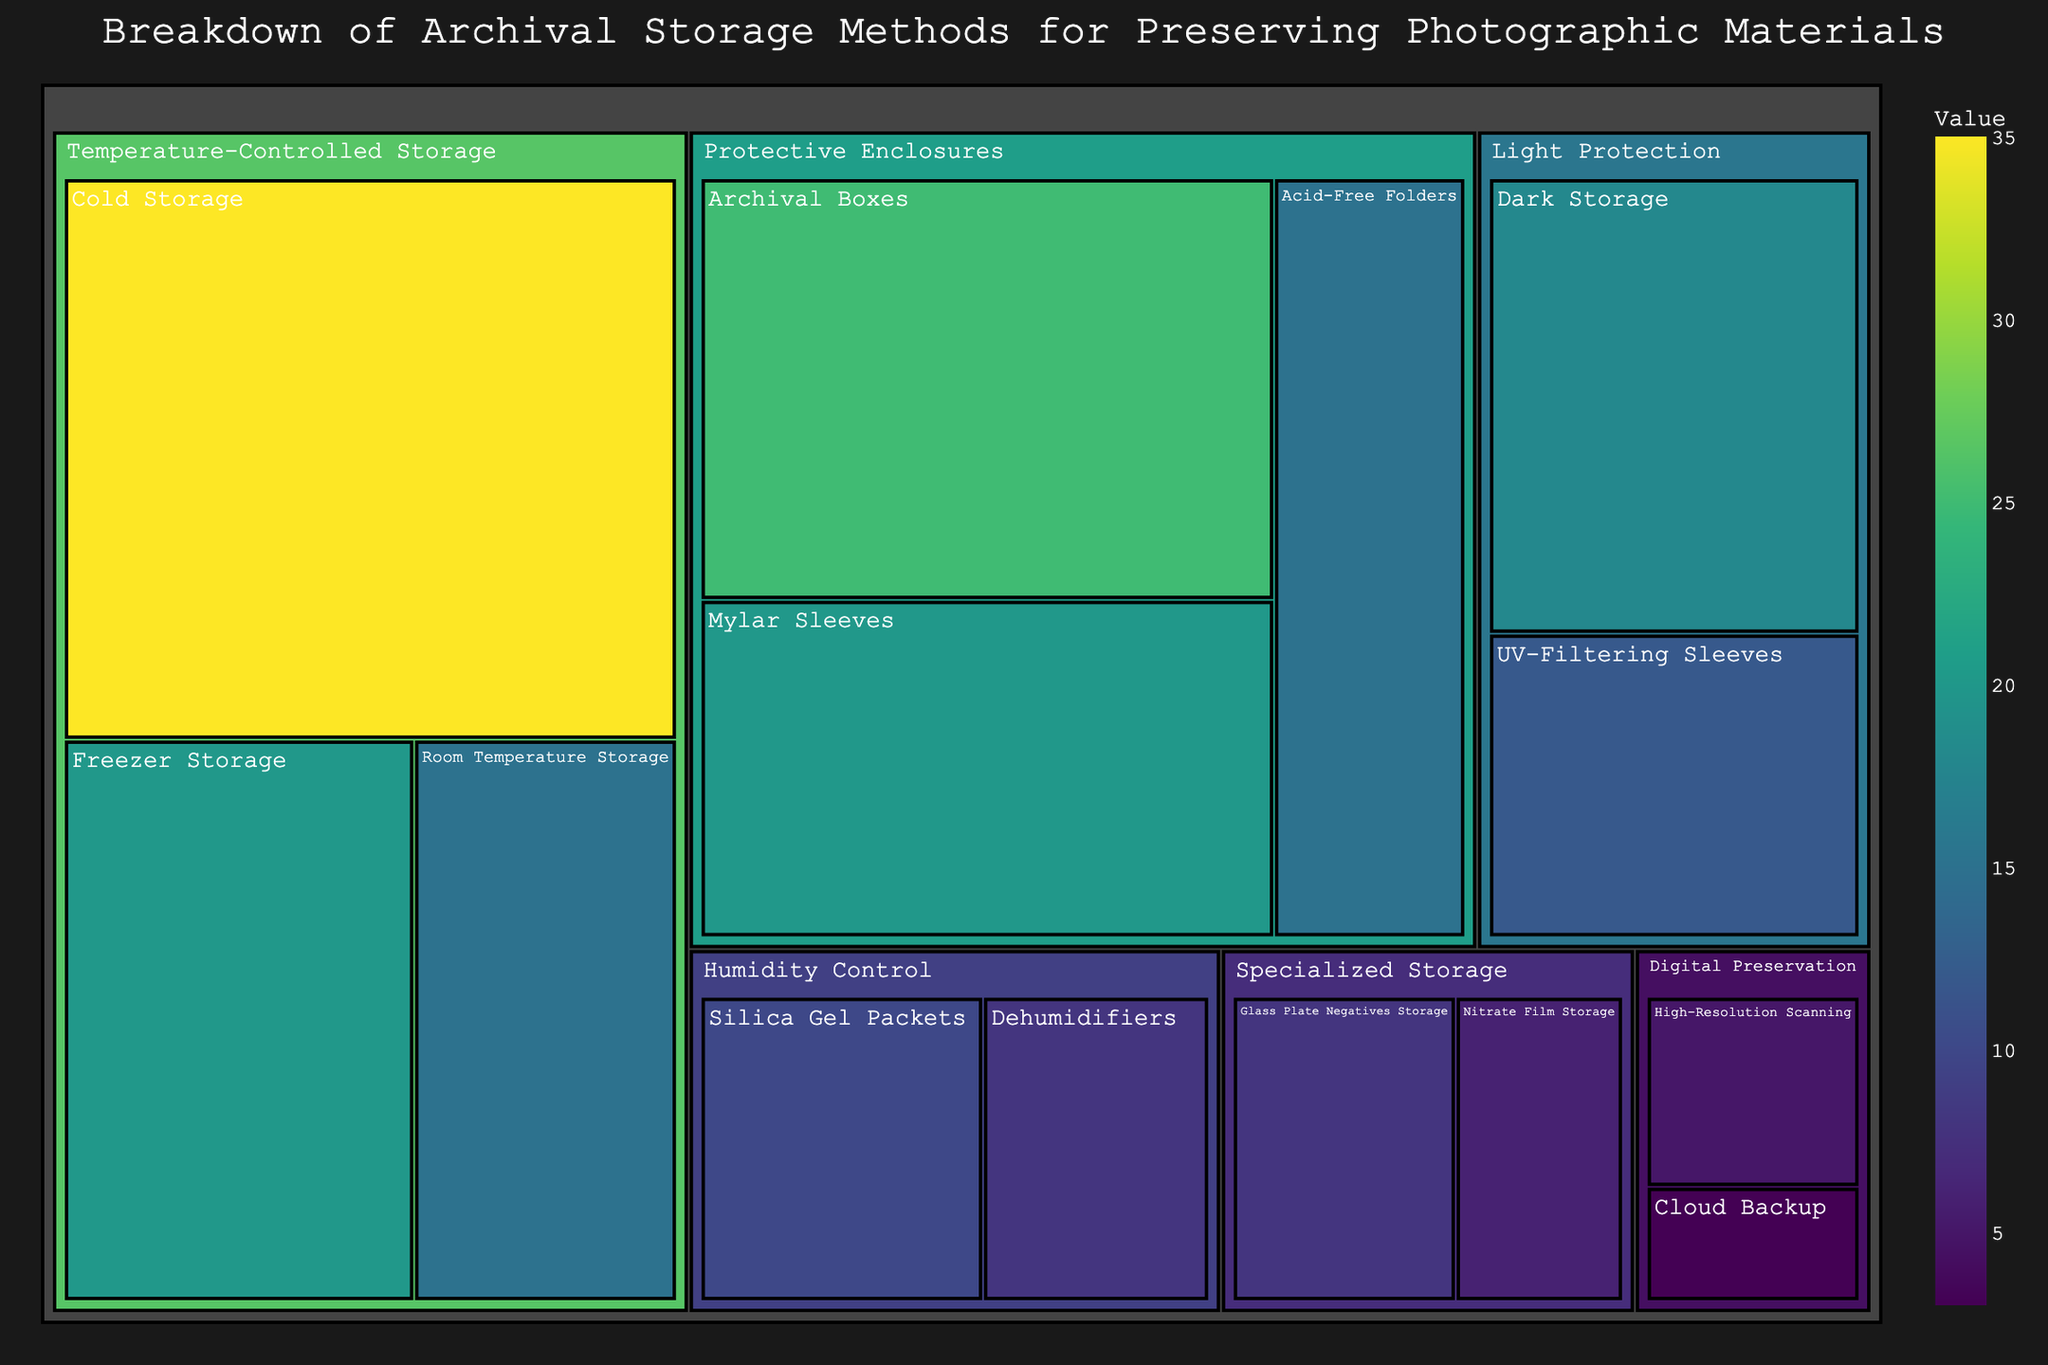What is the total value for Temperature-Controlled Storage? To find the total value for Temperature-Controlled Storage, sum the values of its subcategories: Cold Storage (35), Freezer Storage (20), and Room Temperature Storage (15). 35 + 20 + 15 = 70
Answer: 70 Which subcategory has the highest value? Identify the highest value among all subcategories. Cold Storage under Temperature-Controlled Storage has a value of 35, which is the highest.
Answer: Cold Storage What is the combined value for Protective Enclosures and Humidity Control categories? Sum the total values of the subcategories within Protective Enclosures and Humidity Control. Protective Enclosures has Archival Boxes (25), Mylar Sleeves (20), Acid-Free Folders (15) summing to 60. Humidity Control has Silica Gel Packets (10) and Dehumidifiers (8) summing to 18. 60 + 18 = 78
Answer: 78 How does the value of Dark Storage compare to UV-Filtering Sleeves under Light Protection? Compare the values of Dark Storage (18) and UV-Filtering Sleeves (12) under Light Protection. Dark Storage has a higher value.
Answer: Dark Storage > UV-Filtering Sleeves Which category has the lowest combined value? Sum the values of subcategories under each category and identify the lowest. Digital Preservation has High-Resolution Scanning (5) and Cloud Backup (3), totaling 8, which is the lowest.
Answer: Digital Preservation What is the difference in value between Archival Boxes and Mylar Sleeves under Protective Enclosures? Subtract the value of Mylar Sleeves (20) from Archival Boxes (25). 25 - 20 = 5
Answer: 5 What's the average value of the subcategories under Specialized Storage? Sum the values of subcategories (Glass Plate Negatives Storage (8) and Nitrate Film Storage (6)), then divide by the number of subcategories (2). (8 + 6) / 2 = 7
Answer: 7 Which category occupies the largest area in the treemap? The category with the highest combined value will occupy the largest area. Temperature-Controlled Storage has a combined value of 70, which is the highest.
Answer: Temperature-Controlled Storage 